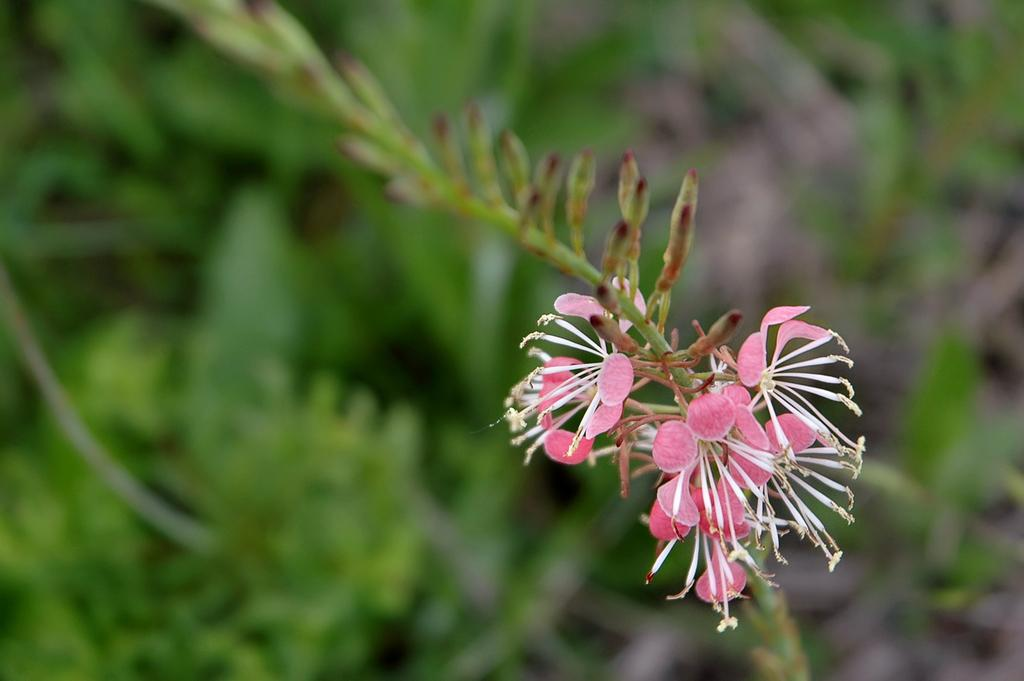What type of living organisms can be seen in the image? There are flowers and buds in the image. How are the flowers and buds connected? The flowers and buds are attached to a stem. What can be seen in the background of the image? There are plants in the background of the image. Can you describe the background's appearance? The background of the image is blurry. What type of glass object is visible in the image? There is no glass object present in the image; it features flowers, buds, and plants. Can you tell me how many twigs are depicted in the image? There is no mention of twigs in the image; it features flowers, buds, and plants connected by stems. 